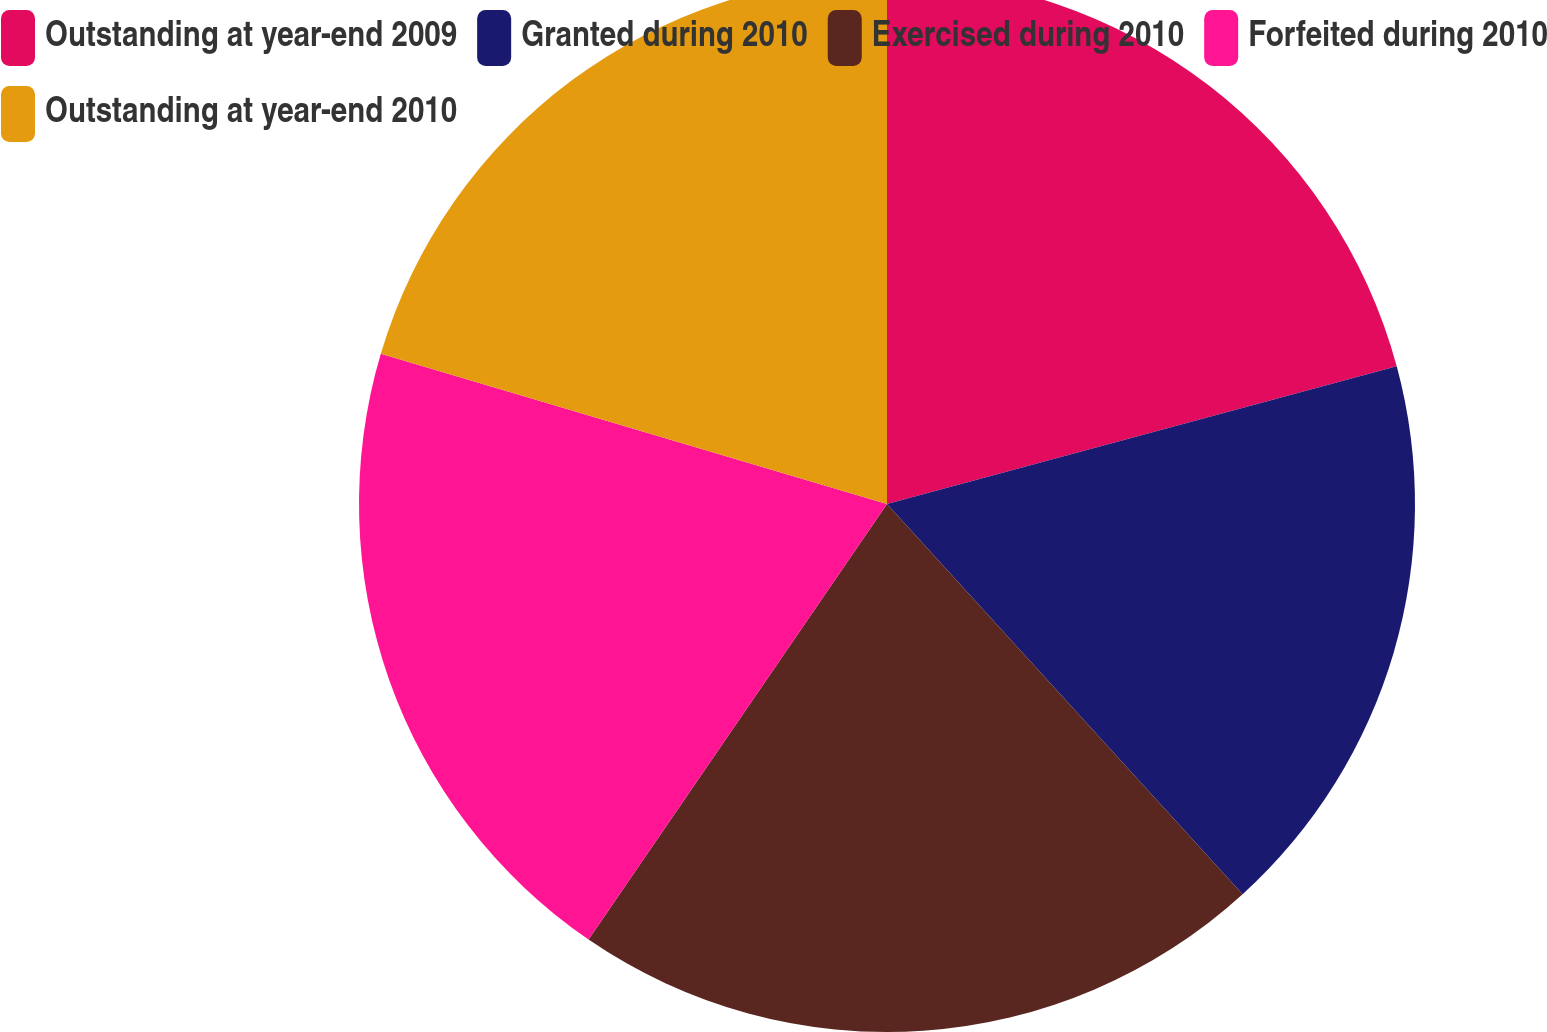Convert chart. <chart><loc_0><loc_0><loc_500><loc_500><pie_chart><fcel>Outstanding at year-end 2009<fcel>Granted during 2010<fcel>Exercised during 2010<fcel>Forfeited during 2010<fcel>Outstanding at year-end 2010<nl><fcel>20.8%<fcel>17.44%<fcel>21.32%<fcel>20.03%<fcel>20.41%<nl></chart> 